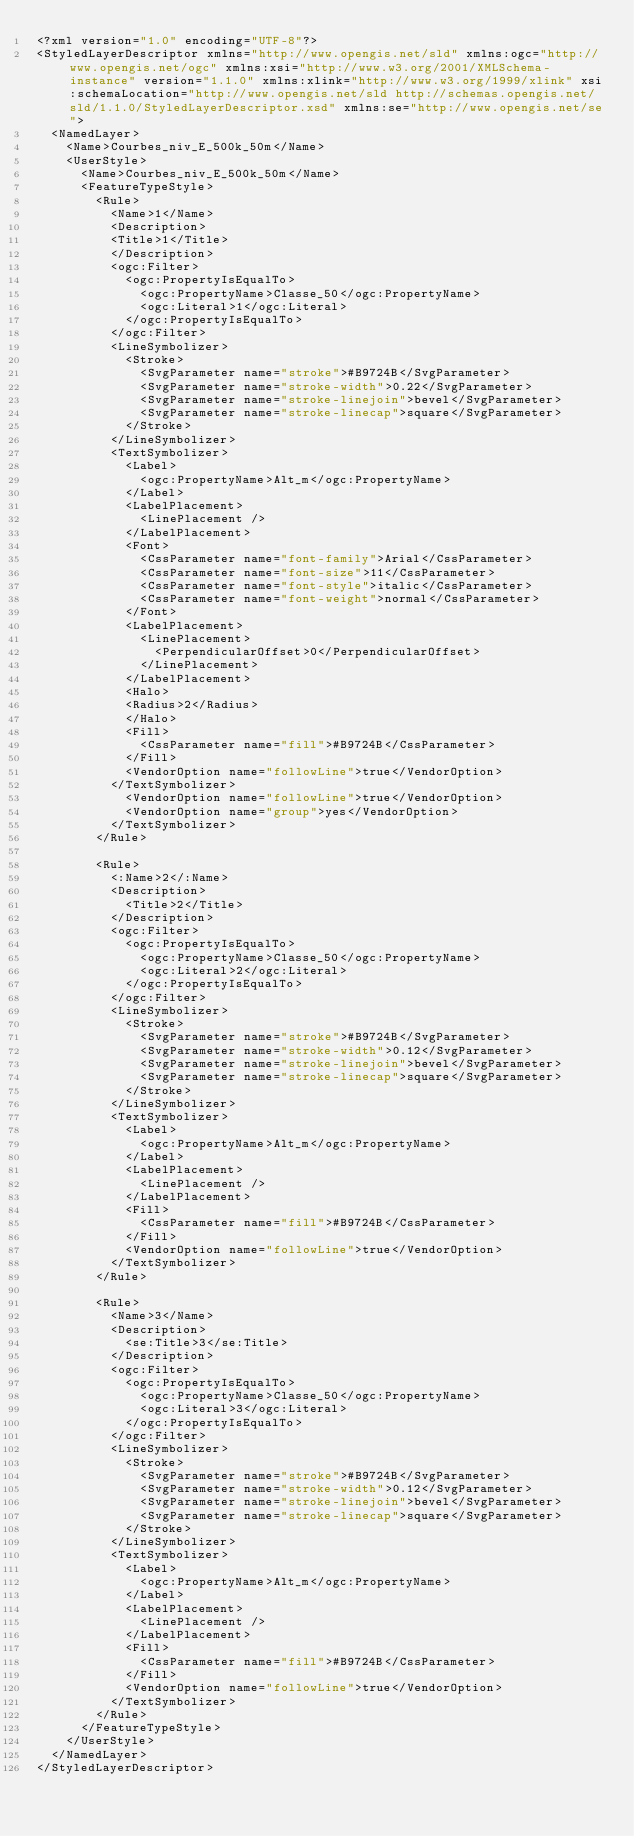<code> <loc_0><loc_0><loc_500><loc_500><_Scheme_><?xml version="1.0" encoding="UTF-8"?>
<StyledLayerDescriptor xmlns="http://www.opengis.net/sld" xmlns:ogc="http://www.opengis.net/ogc" xmlns:xsi="http://www.w3.org/2001/XMLSchema-instance" version="1.1.0" xmlns:xlink="http://www.w3.org/1999/xlink" xsi:schemaLocation="http://www.opengis.net/sld http://schemas.opengis.net/sld/1.1.0/StyledLayerDescriptor.xsd" xmlns:se="http://www.opengis.net/se">
  <NamedLayer>
    <Name>Courbes_niv_E_500k_50m</Name>
    <UserStyle>
      <Name>Courbes_niv_E_500k_50m</Name>
      <FeatureTypeStyle>
        <Rule>
          <Name>1</Name>
          <Description>
          <Title>1</Title>
          </Description>
          <ogc:Filter>
            <ogc:PropertyIsEqualTo>
              <ogc:PropertyName>Classe_50</ogc:PropertyName>
              <ogc:Literal>1</ogc:Literal>
            </ogc:PropertyIsEqualTo>
          </ogc:Filter>
          <LineSymbolizer>
            <Stroke>
              <SvgParameter name="stroke">#B9724B</SvgParameter>
              <SvgParameter name="stroke-width">0.22</SvgParameter>
              <SvgParameter name="stroke-linejoin">bevel</SvgParameter>
              <SvgParameter name="stroke-linecap">square</SvgParameter>
            </Stroke>
          </LineSymbolizer>
          <TextSymbolizer>
            <Label>
              <ogc:PropertyName>Alt_m</ogc:PropertyName>
            </Label>
            <LabelPlacement>
              <LinePlacement />
            </LabelPlacement>
            <Font>
              <CssParameter name="font-family">Arial</CssParameter>
              <CssParameter name="font-size">11</CssParameter>
              <CssParameter name="font-style">italic</CssParameter>
              <CssParameter name="font-weight">normal</CssParameter>
            </Font>
            <LabelPlacement>
              <LinePlacement>
                <PerpendicularOffset>0</PerpendicularOffset>
              </LinePlacement>
            </LabelPlacement>
            <Halo>
            <Radius>2</Radius>
            </Halo>
            <Fill>
              <CssParameter name="fill">#B9724B</CssParameter>
            </Fill>
            <VendorOption name="followLine">true</VendorOption>
          </TextSymbolizer>
            <VendorOption name="followLine">true</VendorOption>
            <VendorOption name="group">yes</VendorOption>
          </TextSymbolizer>
        </Rule>

        <Rule>
          <:Name>2</:Name>
          <Description>
            <Title>2</Title>
          </Description>
          <ogc:Filter>
            <ogc:PropertyIsEqualTo>
              <ogc:PropertyName>Classe_50</ogc:PropertyName>
              <ogc:Literal>2</ogc:Literal>
            </ogc:PropertyIsEqualTo>
          </ogc:Filter>
          <LineSymbolizer>
            <Stroke>
              <SvgParameter name="stroke">#B9724B</SvgParameter>
              <SvgParameter name="stroke-width">0.12</SvgParameter>
              <SvgParameter name="stroke-linejoin">bevel</SvgParameter>
              <SvgParameter name="stroke-linecap">square</SvgParameter>
            </Stroke>
          </LineSymbolizer>
          <TextSymbolizer>
            <Label>
              <ogc:PropertyName>Alt_m</ogc:PropertyName>
            </Label>
            <LabelPlacement>
              <LinePlacement />
            </LabelPlacement>
            <Fill>
              <CssParameter name="fill">#B9724B</CssParameter>
            </Fill>
            <VendorOption name="followLine">true</VendorOption>
          </TextSymbolizer>
        </Rule>

        <Rule>
          <Name>3</Name>
          <Description>
            <se:Title>3</se:Title>
          </Description>
          <ogc:Filter>
            <ogc:PropertyIsEqualTo>
              <ogc:PropertyName>Classe_50</ogc:PropertyName>
              <ogc:Literal>3</ogc:Literal>
            </ogc:PropertyIsEqualTo>
          </ogc:Filter>
          <LineSymbolizer>
            <Stroke>
              <SvgParameter name="stroke">#B9724B</SvgParameter>
              <SvgParameter name="stroke-width">0.12</SvgParameter>
              <SvgParameter name="stroke-linejoin">bevel</SvgParameter>
              <SvgParameter name="stroke-linecap">square</SvgParameter>
            </Stroke>
          </LineSymbolizer>
          <TextSymbolizer>
            <Label>
              <ogc:PropertyName>Alt_m</ogc:PropertyName>
            </Label>
            <LabelPlacement>
              <LinePlacement />
            </LabelPlacement>
            <Fill>
              <CssParameter name="fill">#B9724B</CssParameter>
            </Fill>
            <VendorOption name="followLine">true</VendorOption>
          </TextSymbolizer>
        </Rule>
      </FeatureTypeStyle>
    </UserStyle>
  </NamedLayer>
</StyledLayerDescriptor></code> 